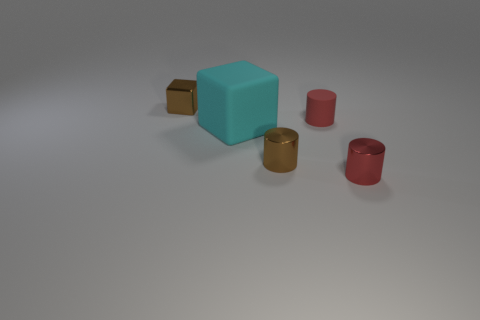Subtract all rubber cylinders. How many cylinders are left? 2 Add 1 red metallic cylinders. How many objects exist? 6 Subtract all yellow spheres. How many red cylinders are left? 2 Subtract all red cylinders. How many cylinders are left? 1 Subtract all cylinders. How many objects are left? 2 Subtract all large green shiny things. Subtract all large things. How many objects are left? 4 Add 3 big rubber blocks. How many big rubber blocks are left? 4 Add 5 green rubber cylinders. How many green rubber cylinders exist? 5 Subtract 0 blue cubes. How many objects are left? 5 Subtract all gray cylinders. Subtract all cyan blocks. How many cylinders are left? 3 